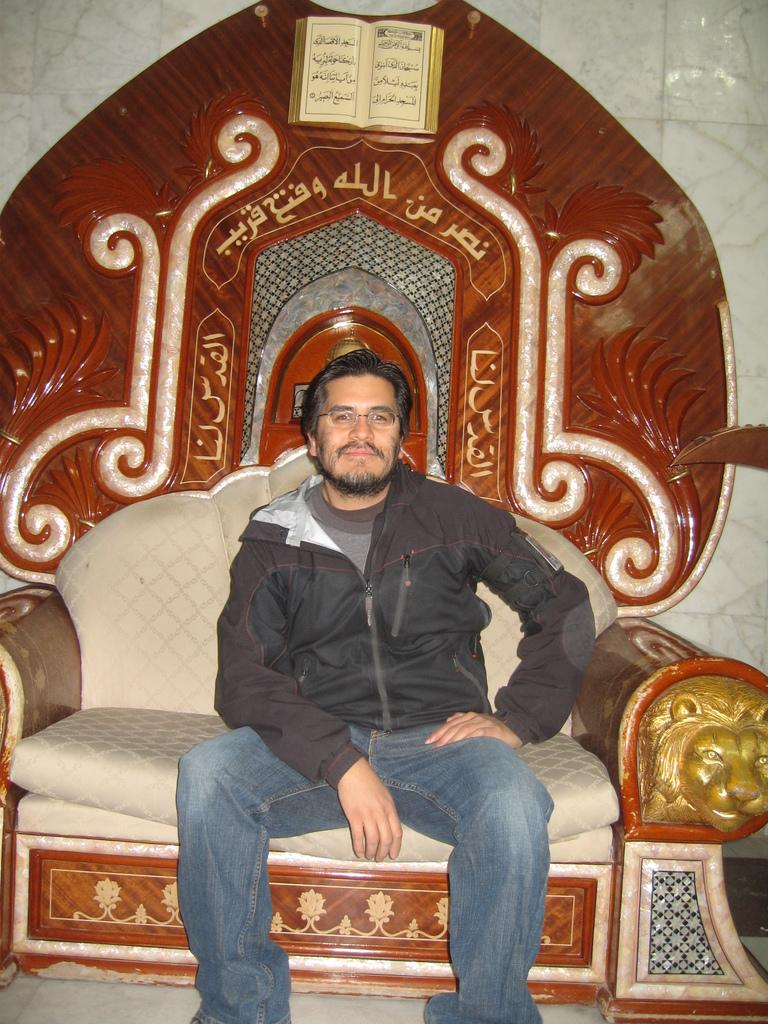What is the main subject of the image? The main subject of the image is a man. What is the man doing in the image? The man is sitting on a chair in the image. Can you describe any accessories the man is wearing? The man is wearing glasses (specs) in the image. What is the man's facial expression in the image? The man has a smile on his face in the image. What type of health issues is the man experiencing in the image? There is no indication of any health issues in the image; the man is sitting and smiling. What territory is the man claiming in the image? There is no indication of the man claiming any territory in the image; he is simply sitting on a chair. 